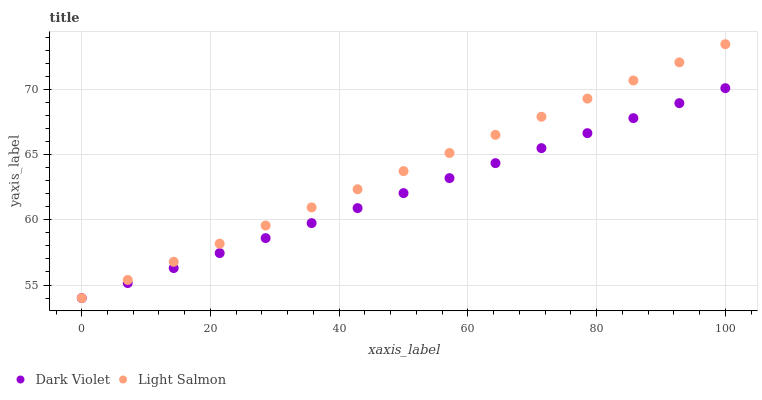Does Dark Violet have the minimum area under the curve?
Answer yes or no. Yes. Does Light Salmon have the maximum area under the curve?
Answer yes or no. Yes. Does Dark Violet have the maximum area under the curve?
Answer yes or no. No. Is Light Salmon the smoothest?
Answer yes or no. Yes. Is Dark Violet the roughest?
Answer yes or no. Yes. Is Dark Violet the smoothest?
Answer yes or no. No. Does Light Salmon have the lowest value?
Answer yes or no. Yes. Does Light Salmon have the highest value?
Answer yes or no. Yes. Does Dark Violet have the highest value?
Answer yes or no. No. Does Dark Violet intersect Light Salmon?
Answer yes or no. Yes. Is Dark Violet less than Light Salmon?
Answer yes or no. No. Is Dark Violet greater than Light Salmon?
Answer yes or no. No. 